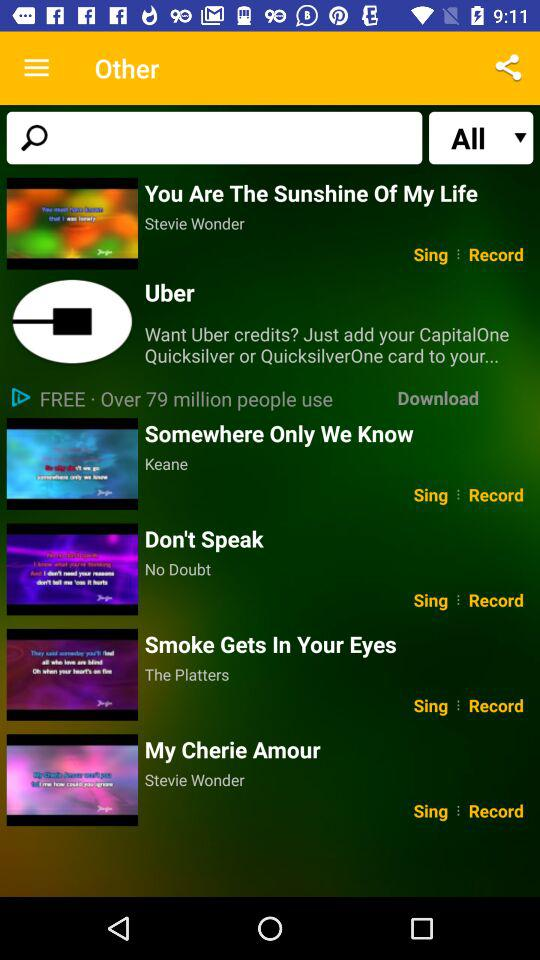Who sang the song "My Cherie Amour"? The song "My Cherie Amour" was sung by Stevie Wonder. 